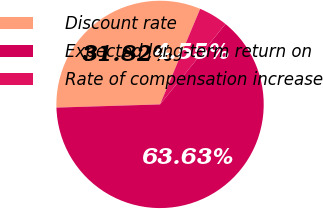<chart> <loc_0><loc_0><loc_500><loc_500><pie_chart><fcel>Discount rate<fcel>Expected long-term return on<fcel>Rate of compensation increase<nl><fcel>31.82%<fcel>63.64%<fcel>4.55%<nl></chart> 